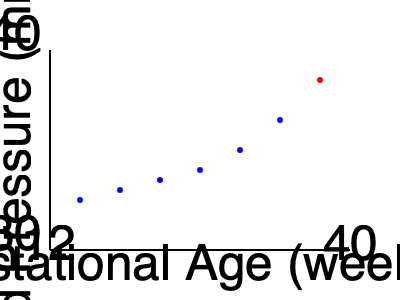Based on the scatter plot showing blood pressure readings during pregnancy, which data point might indicate a potential concern for preeclampsia, and at approximately what gestational age does this occur? To interpret this scatter plot and identify a potential concern for preeclampsia, we need to follow these steps:

1. Understand the axes:
   - X-axis represents gestational age from 12 to 40 weeks
   - Y-axis represents blood pressure from 80 to 140 mmHg

2. Observe the trend:
   - Most data points (blue) show a gradual increase in blood pressure as gestational age increases, which is normal during pregnancy

3. Identify the outlier:
   - There is one red data point that stands out from the others

4. Assess the outlier:
   - This point shows a significantly higher blood pressure compared to the trend
   - It occurs near the end of pregnancy (around 38-40 weeks gestational age)
   - The blood pressure reading appears to be above 140 mmHg

5. Relate to preeclampsia:
   - Preeclampsia is characterized by high blood pressure (typically >140/90 mmHg) after 20 weeks of pregnancy
   - The red data point meets this criterion

6. Estimate gestational age:
   - The concerning data point is at the far right of the graph
   - This corresponds to approximately 38-40 weeks of gestation

Therefore, the red data point at around 38-40 weeks gestation with a blood pressure reading above 140 mmHg indicates a potential concern for preeclampsia.
Answer: The red data point at approximately 38-40 weeks gestation 